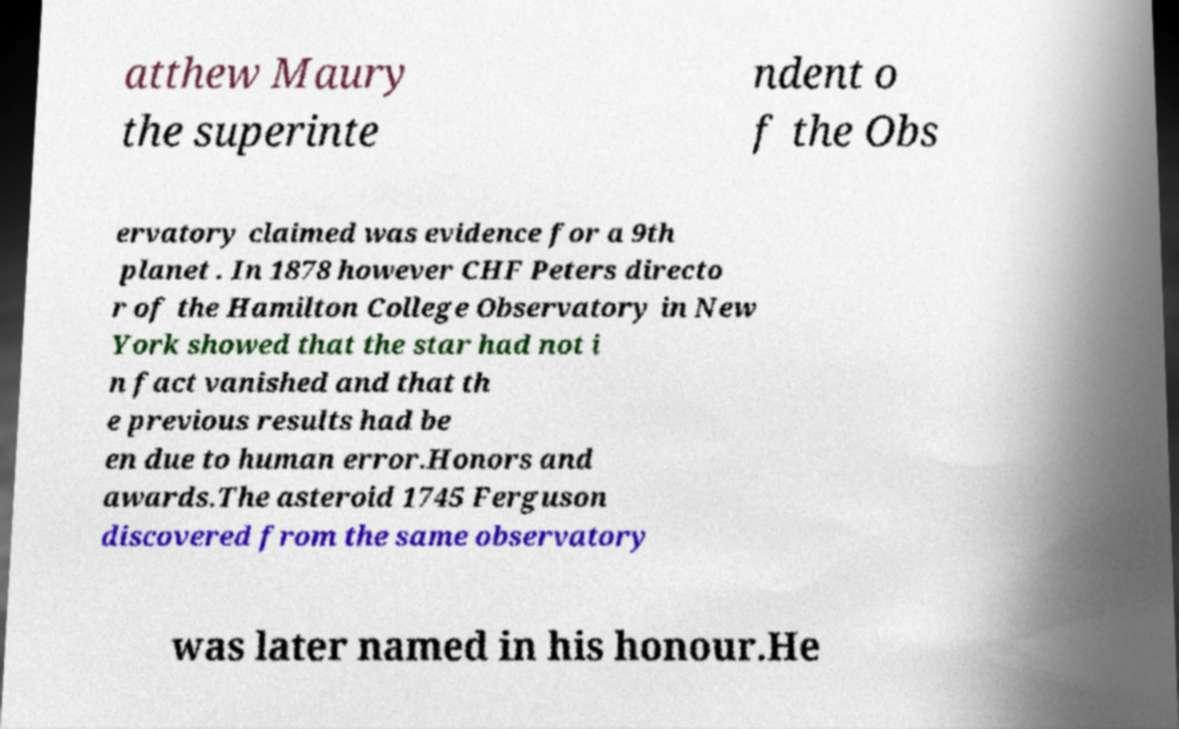I need the written content from this picture converted into text. Can you do that? atthew Maury the superinte ndent o f the Obs ervatory claimed was evidence for a 9th planet . In 1878 however CHF Peters directo r of the Hamilton College Observatory in New York showed that the star had not i n fact vanished and that th e previous results had be en due to human error.Honors and awards.The asteroid 1745 Ferguson discovered from the same observatory was later named in his honour.He 